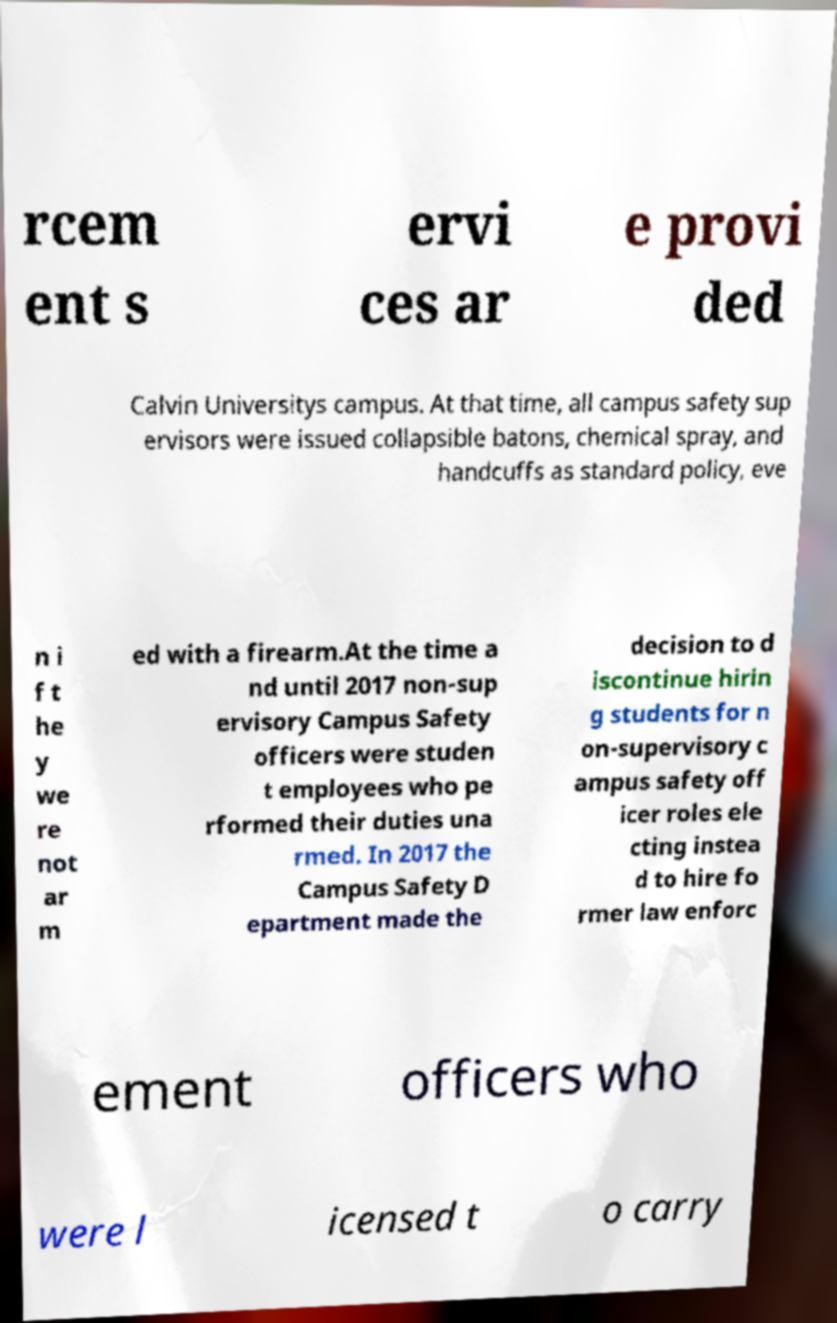Please read and relay the text visible in this image. What does it say? rcem ent s ervi ces ar e provi ded Calvin Universitys campus. At that time, all campus safety sup ervisors were issued collapsible batons, chemical spray, and handcuffs as standard policy, eve n i f t he y we re not ar m ed with a firearm.At the time a nd until 2017 non-sup ervisory Campus Safety officers were studen t employees who pe rformed their duties una rmed. In 2017 the Campus Safety D epartment made the decision to d iscontinue hirin g students for n on-supervisory c ampus safety off icer roles ele cting instea d to hire fo rmer law enforc ement officers who were l icensed t o carry 